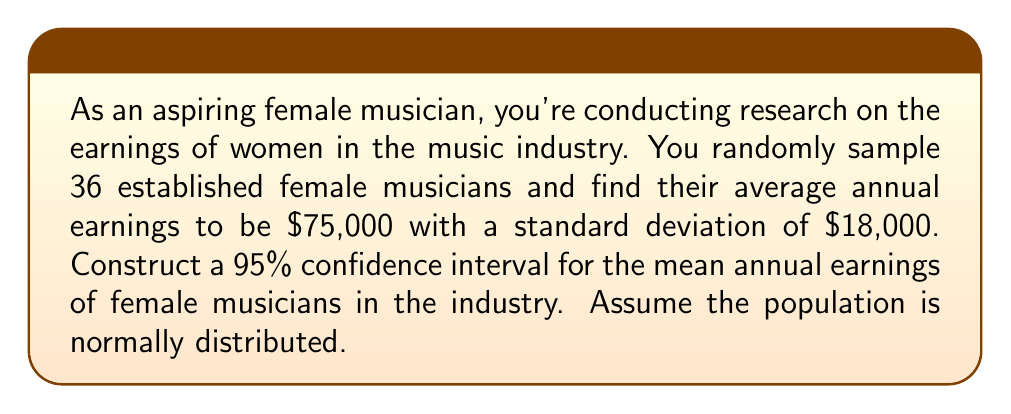Show me your answer to this math problem. Let's approach this step-by-step:

1) We're given:
   - Sample size: $n = 36$
   - Sample mean: $\bar{x} = \$75,000$
   - Sample standard deviation: $s = \$18,000$
   - Confidence level: 95%

2) The formula for a confidence interval is:

   $$\bar{x} \pm t_{\alpha/2} \cdot \frac{s}{\sqrt{n}}$$

   where $t_{\alpha/2}$ is the t-value for a 95% confidence level with $n-1$ degrees of freedom.

3) For a 95% confidence level and 35 degrees of freedom, $t_{\alpha/2} = 2.030$ (from t-distribution table)

4) Now, let's calculate the margin of error:

   $$\text{Margin of Error} = t_{\alpha/2} \cdot \frac{s}{\sqrt{n}} = 2.030 \cdot \frac{18,000}{\sqrt{36}} = 2.030 \cdot 3,000 = \$6,090$$

5) Finally, we can construct the confidence interval:

   Lower bound: $75,000 - 6,090 = \$68,910$
   Upper bound: $75,000 + 6,090 = \$81,090$

Thus, we are 95% confident that the true mean annual earnings of female musicians in the industry falls between $68,910 and $81,090.
Answer: ($68,910, $81,090) 